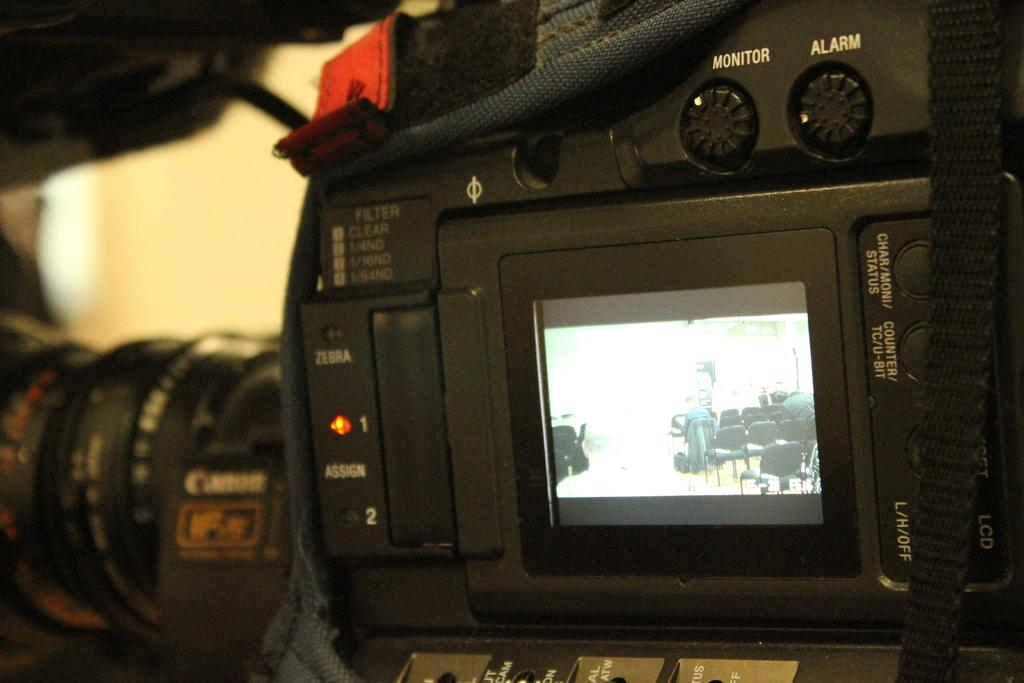What is the main subject in the center of the image? There are cameras in the center of the image. What is located in front of the cameras? There are chairs in front of the cameras. What are the people doing while sitting on the chairs? The people are sitting on the chairs. What can be seen in the background of the image? There is a wall in the background of the image. What type of zinc is being used to support the chairs in the image? There is no zinc present in the image, and the chairs are not supported by any zinc. 